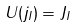Convert formula to latex. <formula><loc_0><loc_0><loc_500><loc_500>U ( j _ { I } ) = J _ { I }</formula> 